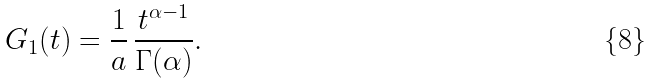Convert formula to latex. <formula><loc_0><loc_0><loc_500><loc_500>G _ { 1 } ( t ) = \frac { 1 } { a } \, \frac { t ^ { \alpha - 1 } } { \Gamma ( \alpha ) } .</formula> 